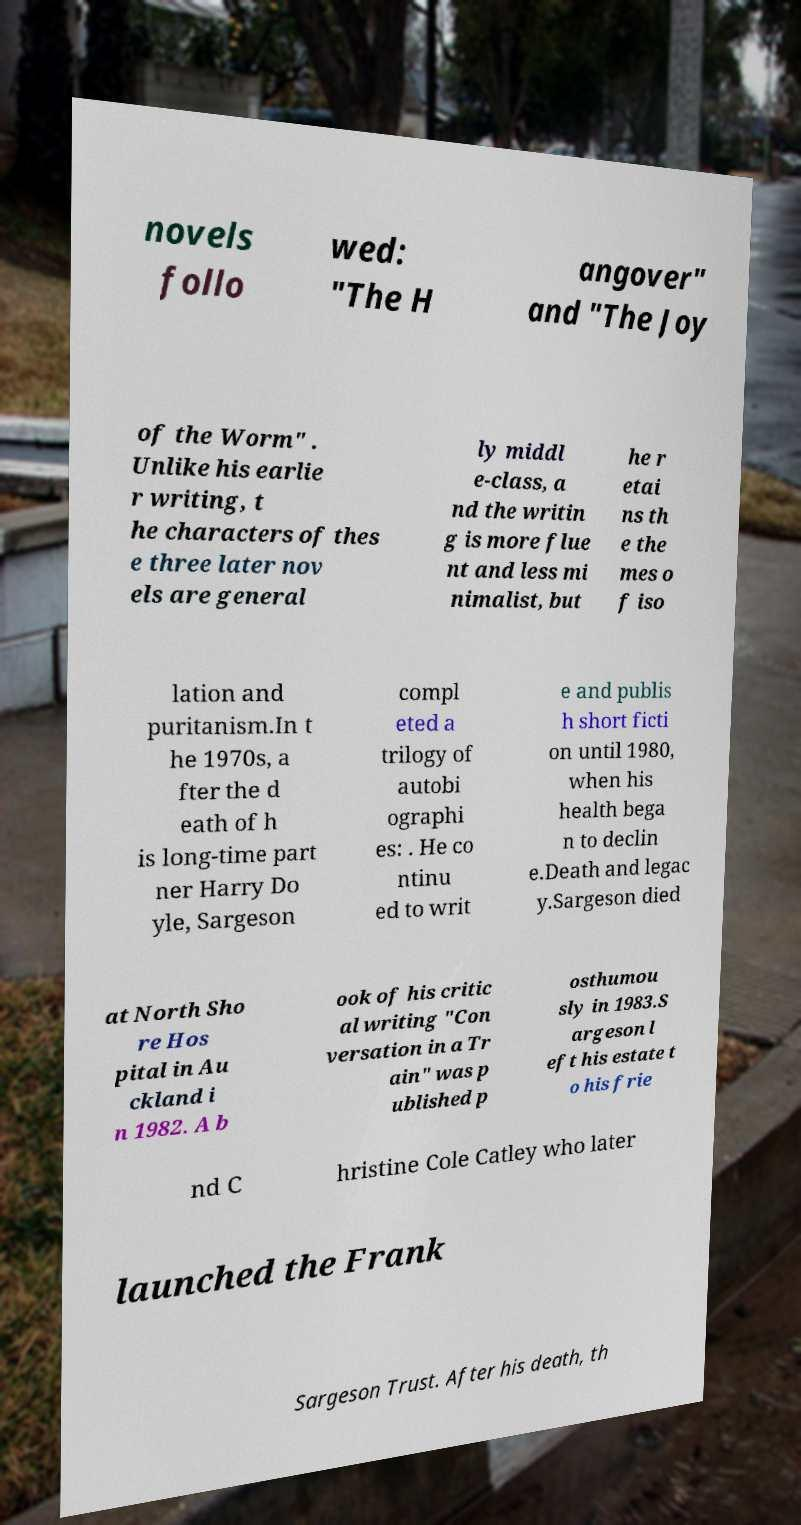Can you accurately transcribe the text from the provided image for me? novels follo wed: "The H angover" and "The Joy of the Worm" . Unlike his earlie r writing, t he characters of thes e three later nov els are general ly middl e-class, a nd the writin g is more flue nt and less mi nimalist, but he r etai ns th e the mes o f iso lation and puritanism.In t he 1970s, a fter the d eath of h is long-time part ner Harry Do yle, Sargeson compl eted a trilogy of autobi ographi es: . He co ntinu ed to writ e and publis h short ficti on until 1980, when his health bega n to declin e.Death and legac y.Sargeson died at North Sho re Hos pital in Au ckland i n 1982. A b ook of his critic al writing "Con versation in a Tr ain" was p ublished p osthumou sly in 1983.S argeson l eft his estate t o his frie nd C hristine Cole Catley who later launched the Frank Sargeson Trust. After his death, th 